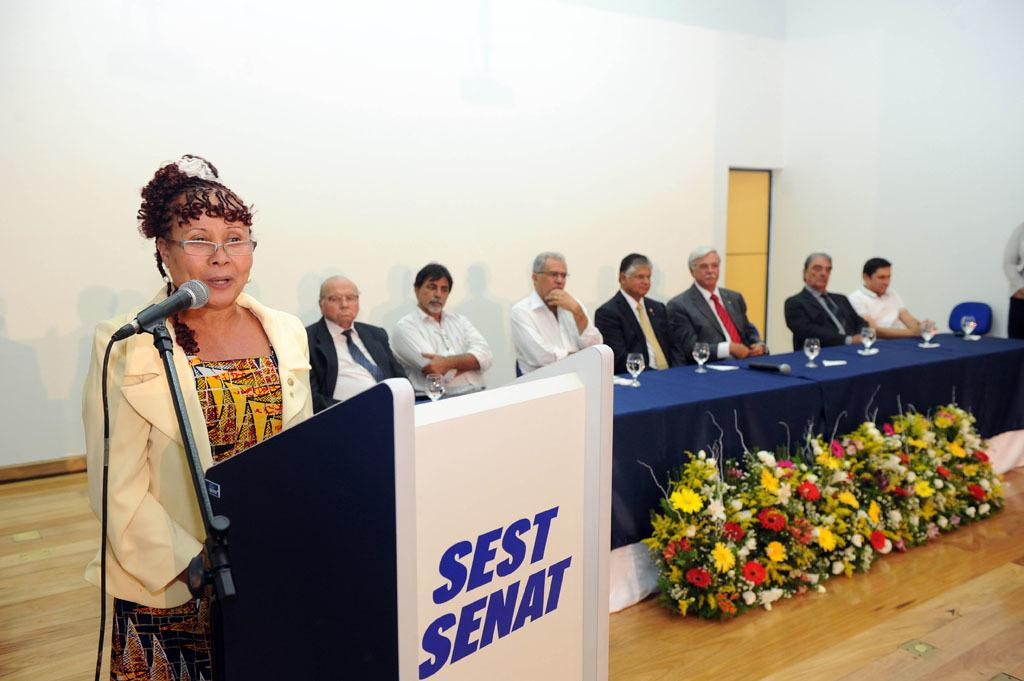Provide a one-sentence caption for the provided image. A woman is speaking at a podium that says "SEST SENAT" in front of a panel of men. 